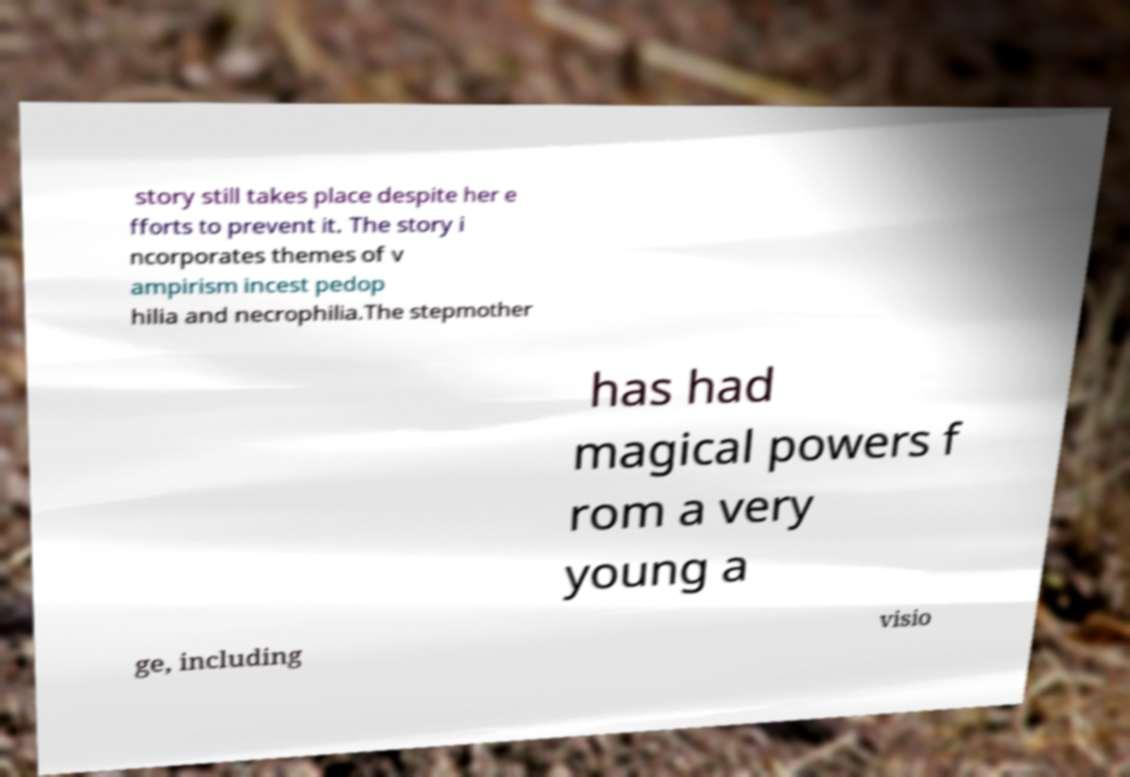Can you read and provide the text displayed in the image?This photo seems to have some interesting text. Can you extract and type it out for me? story still takes place despite her e fforts to prevent it. The story i ncorporates themes of v ampirism incest pedop hilia and necrophilia.The stepmother has had magical powers f rom a very young a ge, including visio 